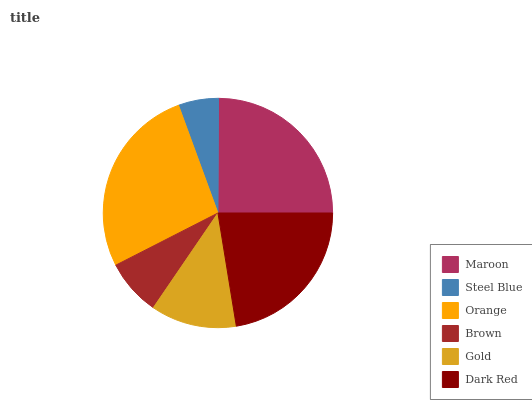Is Steel Blue the minimum?
Answer yes or no. Yes. Is Orange the maximum?
Answer yes or no. Yes. Is Orange the minimum?
Answer yes or no. No. Is Steel Blue the maximum?
Answer yes or no. No. Is Orange greater than Steel Blue?
Answer yes or no. Yes. Is Steel Blue less than Orange?
Answer yes or no. Yes. Is Steel Blue greater than Orange?
Answer yes or no. No. Is Orange less than Steel Blue?
Answer yes or no. No. Is Dark Red the high median?
Answer yes or no. Yes. Is Gold the low median?
Answer yes or no. Yes. Is Brown the high median?
Answer yes or no. No. Is Dark Red the low median?
Answer yes or no. No. 